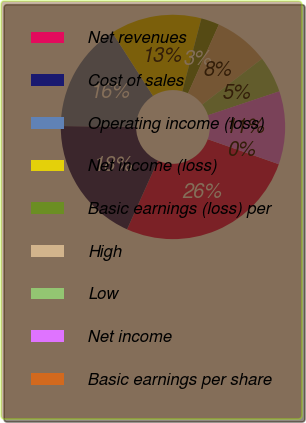Convert chart to OTSL. <chart><loc_0><loc_0><loc_500><loc_500><pie_chart><fcel>Net revenues<fcel>Cost of sales<fcel>Operating income (loss)<fcel>Net income (loss)<fcel>Basic earnings (loss) per<fcel>High<fcel>Low<fcel>Net income<fcel>Basic earnings per share<nl><fcel>26.32%<fcel>18.42%<fcel>15.79%<fcel>13.16%<fcel>2.63%<fcel>7.89%<fcel>5.26%<fcel>10.53%<fcel>0.0%<nl></chart> 